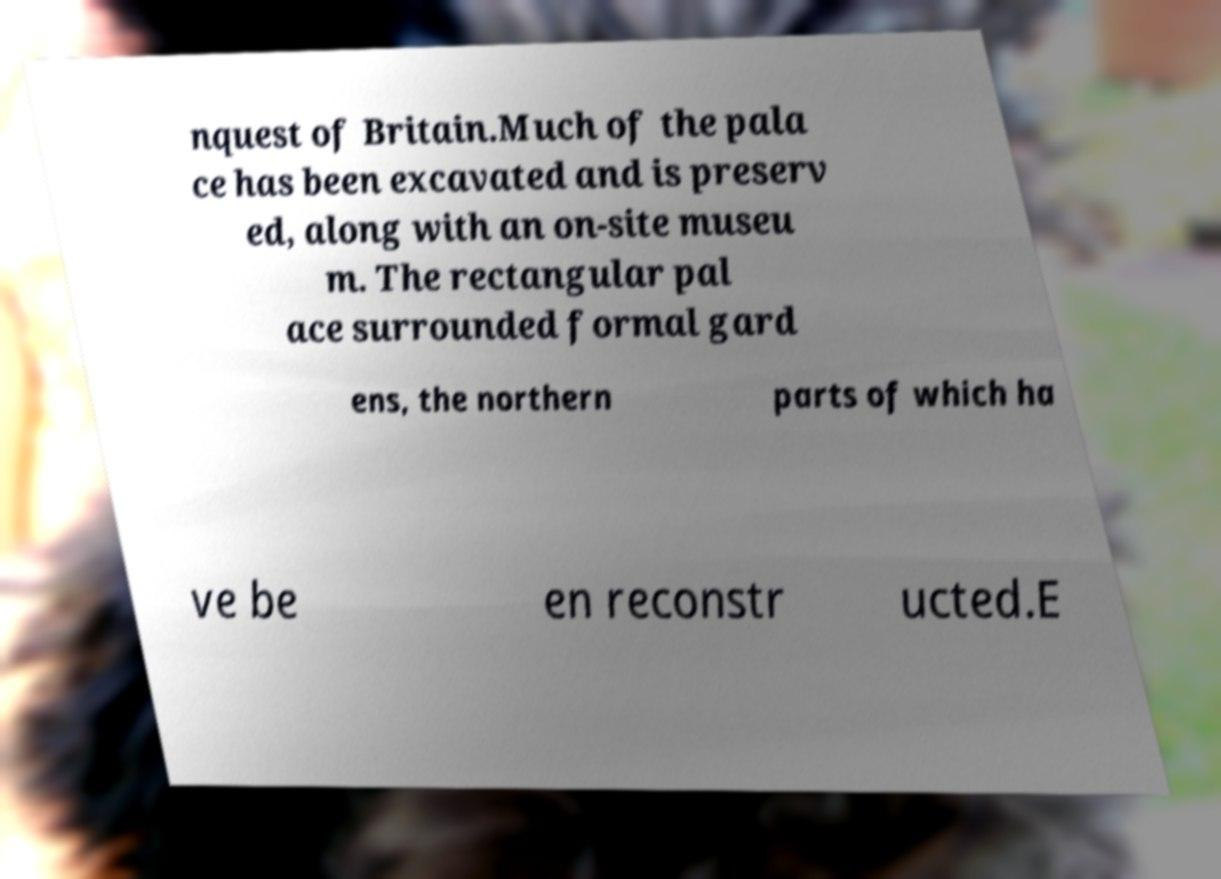Please identify and transcribe the text found in this image. nquest of Britain.Much of the pala ce has been excavated and is preserv ed, along with an on-site museu m. The rectangular pal ace surrounded formal gard ens, the northern parts of which ha ve be en reconstr ucted.E 